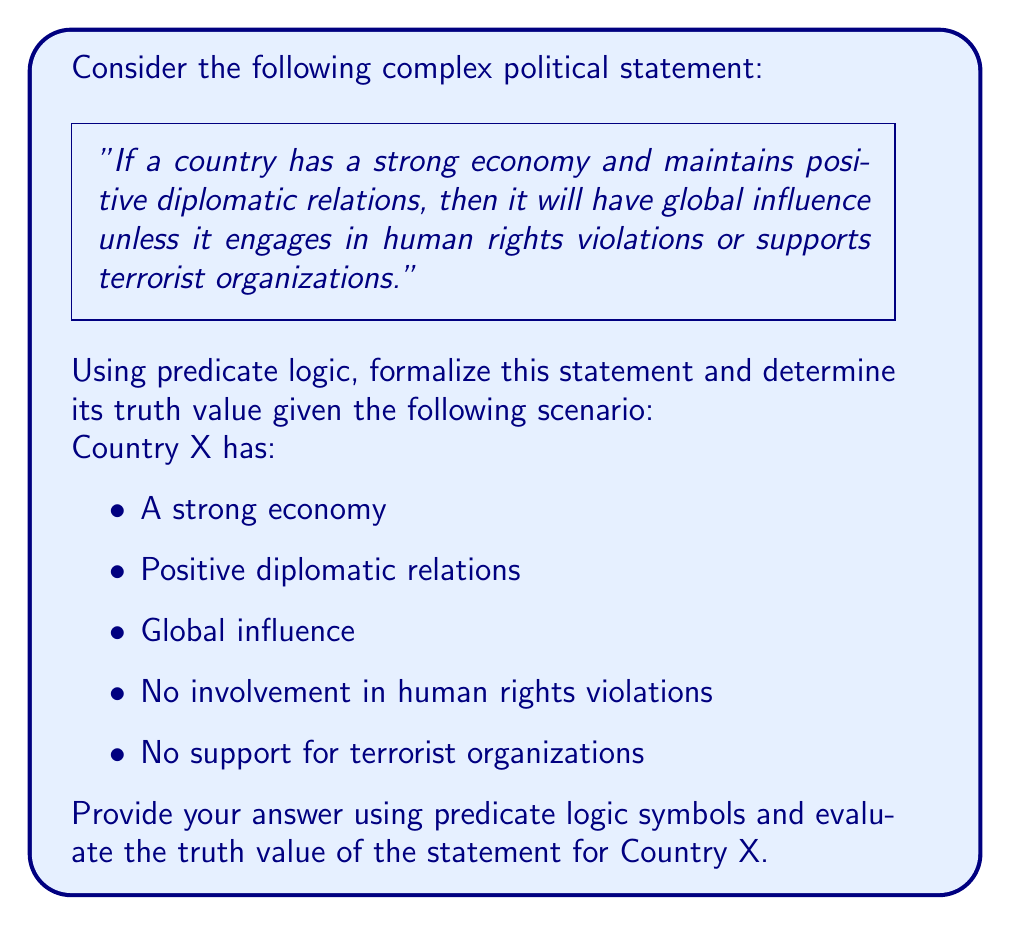Could you help me with this problem? Let's break this down step-by-step:

1) First, we need to define our predicates:
   $E(x)$: x has a strong economy
   $D(x)$: x maintains positive diplomatic relations
   $G(x)$: x has global influence
   $H(x)$: x engages in human rights violations
   $T(x)$: x supports terrorist organizations

2) Now, we can formalize the statement using predicate logic:

   $\forall x [(E(x) \wedge D(x)) \rightarrow (G(x) \vee (H(x) \vee T(x)))]$

3) Let's break down this formula:
   - $\forall x$ means "for all countries x"
   - $(E(x) \wedge D(x))$ represents "has a strong economy and maintains positive diplomatic relations"
   - $\rightarrow$ is the implication symbol ("then")
   - $(G(x) \vee (H(x) \vee T(x)))$ represents "will have global influence unless it engages in human rights violations or supports terrorist organizations"

4) For Country X, we have the following information:
   $E(X)$ is true
   $D(X)$ is true
   $G(X)$ is true
   $H(X)$ is false
   $T(X)$ is false

5) To evaluate the truth value, we need to check if the implication holds:
   - The antecedent $(E(X) \wedge D(X))$ is true because both $E(X)$ and $D(X)$ are true
   - The consequent $(G(X) \vee (H(X) \vee T(X)))$ is true because $G(X)$ is true (we don't need to evaluate $H(X)$ or $T(X)$)

6) Since both the antecedent and consequent are true, the implication is true for Country X.

Therefore, the formalized statement is true for Country X.
Answer: $\forall x [(E(x) \wedge D(x)) \rightarrow (G(x) \vee (H(x) \vee T(x)))]$; True for Country X 